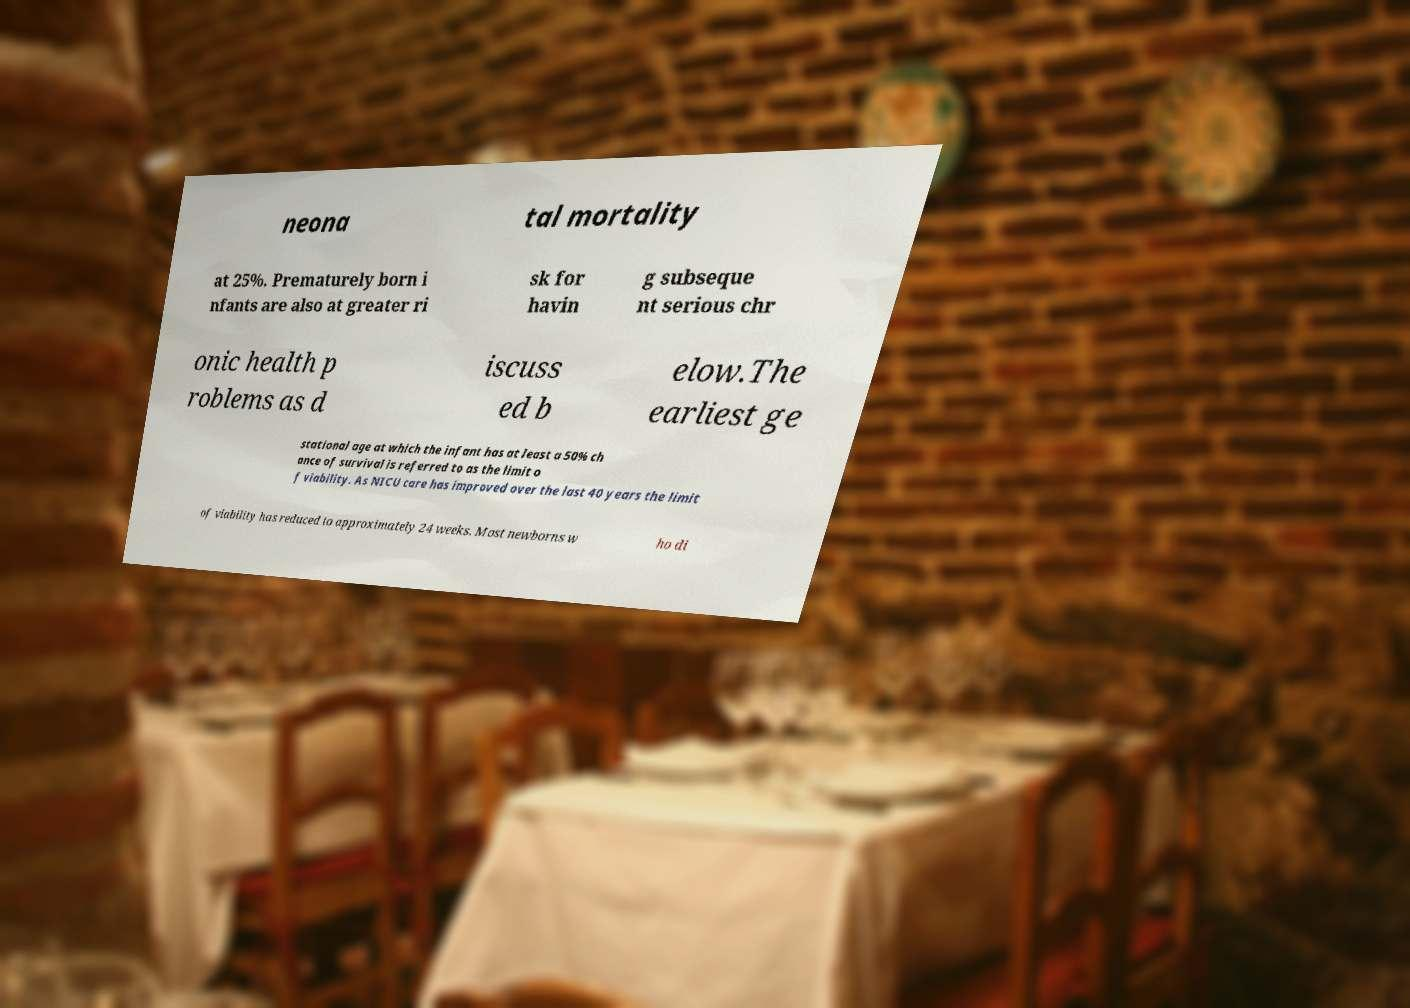Please identify and transcribe the text found in this image. neona tal mortality at 25%. Prematurely born i nfants are also at greater ri sk for havin g subseque nt serious chr onic health p roblems as d iscuss ed b elow.The earliest ge stational age at which the infant has at least a 50% ch ance of survival is referred to as the limit o f viability. As NICU care has improved over the last 40 years the limit of viability has reduced to approximately 24 weeks. Most newborns w ho di 